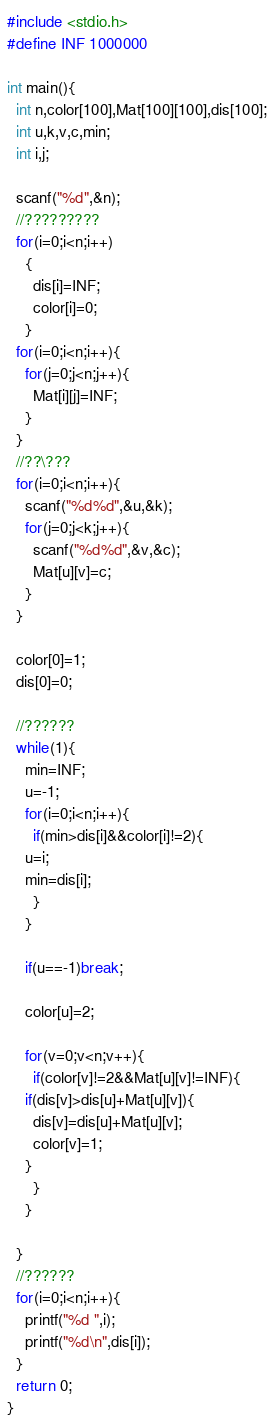Convert code to text. <code><loc_0><loc_0><loc_500><loc_500><_C_>#include <stdio.h>
#define INF 1000000

int main(){
  int n,color[100],Mat[100][100],dis[100];
  int u,k,v,c,min;
  int i,j;
  
  scanf("%d",&n);
  //?????????
  for(i=0;i<n;i++)
    {
      dis[i]=INF;
      color[i]=0;
    }
  for(i=0;i<n;i++){
    for(j=0;j<n;j++){
      Mat[i][j]=INF;
    }
  }
  //??\???
  for(i=0;i<n;i++){
    scanf("%d%d",&u,&k);
    for(j=0;j<k;j++){
      scanf("%d%d",&v,&c);
      Mat[u][v]=c;
    }
  }
  
  color[0]=1;
  dis[0]=0;

  //??????
  while(1){
    min=INF;
    u=-1;
    for(i=0;i<n;i++){
      if(min>dis[i]&&color[i]!=2){
	u=i;
	min=dis[i];
      }
    }
    
    if(u==-1)break;
    
    color[u]=2;
    
    for(v=0;v<n;v++){
      if(color[v]!=2&&Mat[u][v]!=INF){
	if(dis[v]>dis[u]+Mat[u][v]){
	  dis[v]=dis[u]+Mat[u][v];
	  color[v]=1;
	}
      }
    }
    
  }
  //??????
  for(i=0;i<n;i++){
    printf("%d ",i);
    printf("%d\n",dis[i]);
  }
  return 0;
}</code> 